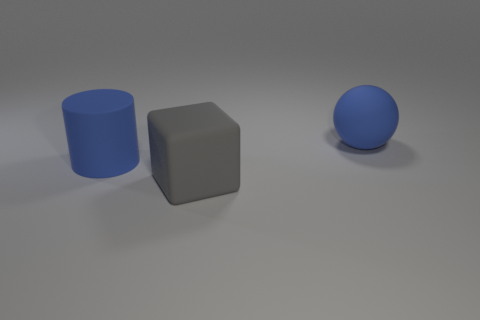Add 3 big gray objects. How many objects exist? 6 Subtract all cubes. How many objects are left? 2 Subtract 1 cylinders. How many cylinders are left? 0 Subtract 1 gray cubes. How many objects are left? 2 Subtract all yellow cylinders. Subtract all yellow cubes. How many cylinders are left? 1 Subtract all brown balls. Subtract all gray blocks. How many objects are left? 2 Add 3 blue matte cylinders. How many blue matte cylinders are left? 4 Add 3 blue rubber things. How many blue rubber things exist? 5 